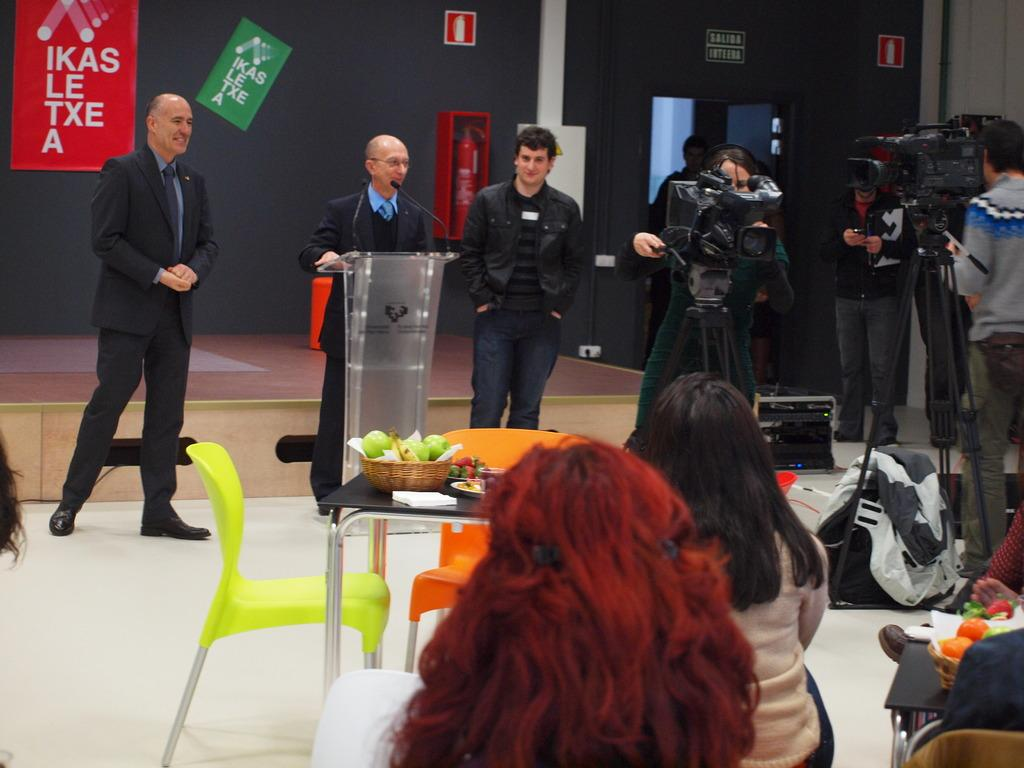Who or what can be seen in the image? There are people in the image. What object is present that might be used for speaking or presenting? There is a podium in the image. What device is visible that might be used for amplifying sound? There is a microphone in the image. What type of signage is present in the image? There are posters with text in the image. What equipment is used for recording or capturing images in the image? There are cameras with stands in the image. What type of seating is available in the image? There are chairs in the image. What can be found on the table in the image? There are food items on a table in the image. Can you describe the plot of the sea visible in the image? There is no sea or plot present in the image; the image features people, a podium, a microphone, posters, cameras, chairs, and food items on a table. 